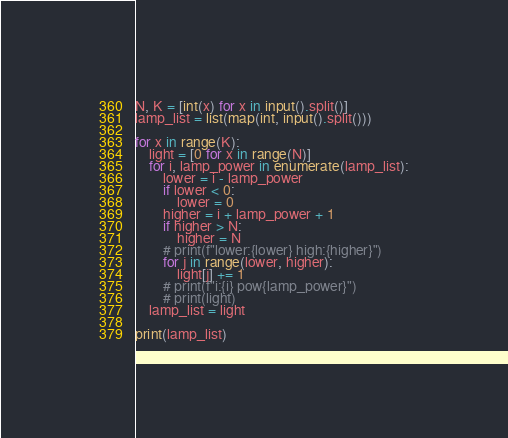Convert code to text. <code><loc_0><loc_0><loc_500><loc_500><_Python_>N, K = [int(x) for x in input().split()]
lamp_list = list(map(int, input().split()))

for x in range(K):
    light = [0 for x in range(N)]
    for i, lamp_power in enumerate(lamp_list):
        lower = i - lamp_power
        if lower < 0:
            lower = 0
        higher = i + lamp_power + 1
        if higher > N:
            higher = N
        # print(f"lower:{lower} high:{higher}")
        for j in range(lower, higher):
            light[j] += 1
        # print(f"i:{i} pow{lamp_power}")
        # print(light)
    lamp_list = light

print(lamp_list)
</code> 